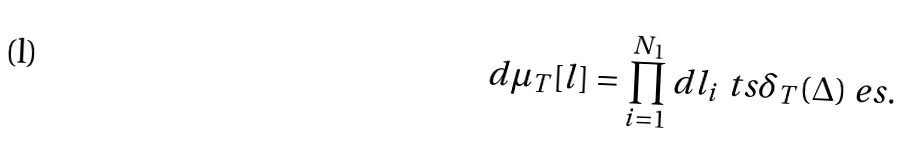Convert formula to latex. <formula><loc_0><loc_0><loc_500><loc_500>d \mu _ { T } [ l ] = \prod _ { i = 1 } ^ { N _ { 1 } } d l _ { i } \ t s \delta _ { T } ( \Delta ) \ e s .</formula> 